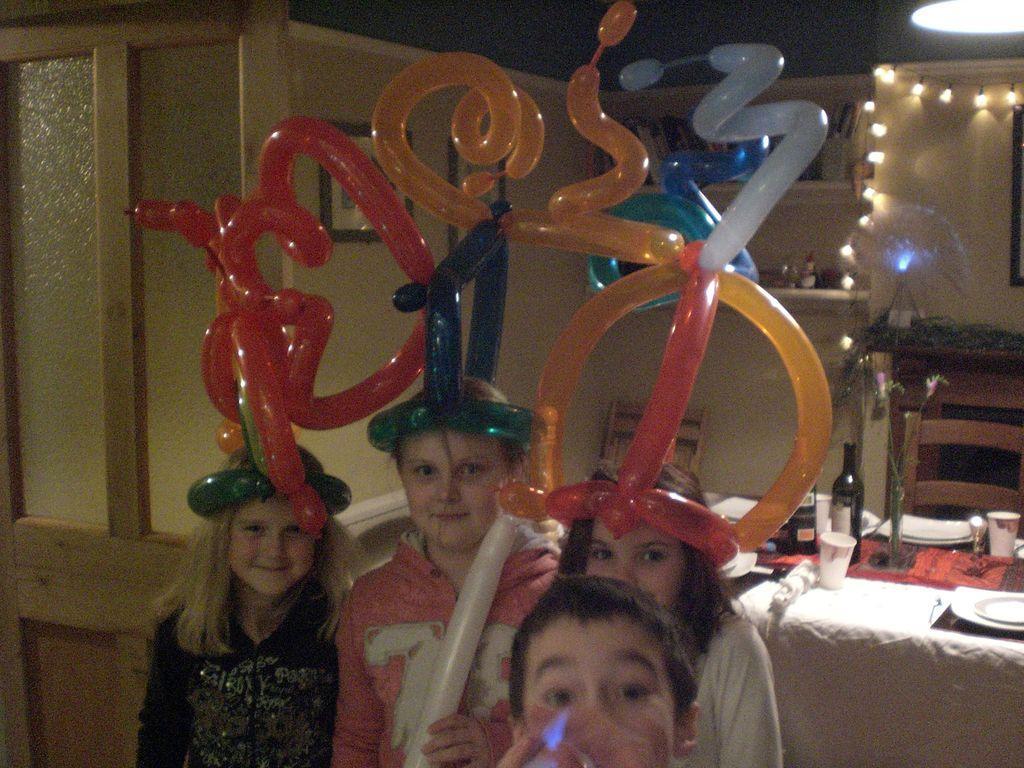Please provide a concise description of this image. This image consists of 4 children at the bottom. They are holding balloons. There are lights in the top right corner. There is a table on the right side. There is a chair near the table. On the table, there are bottle, glass, plates. There is a door on the left side. 